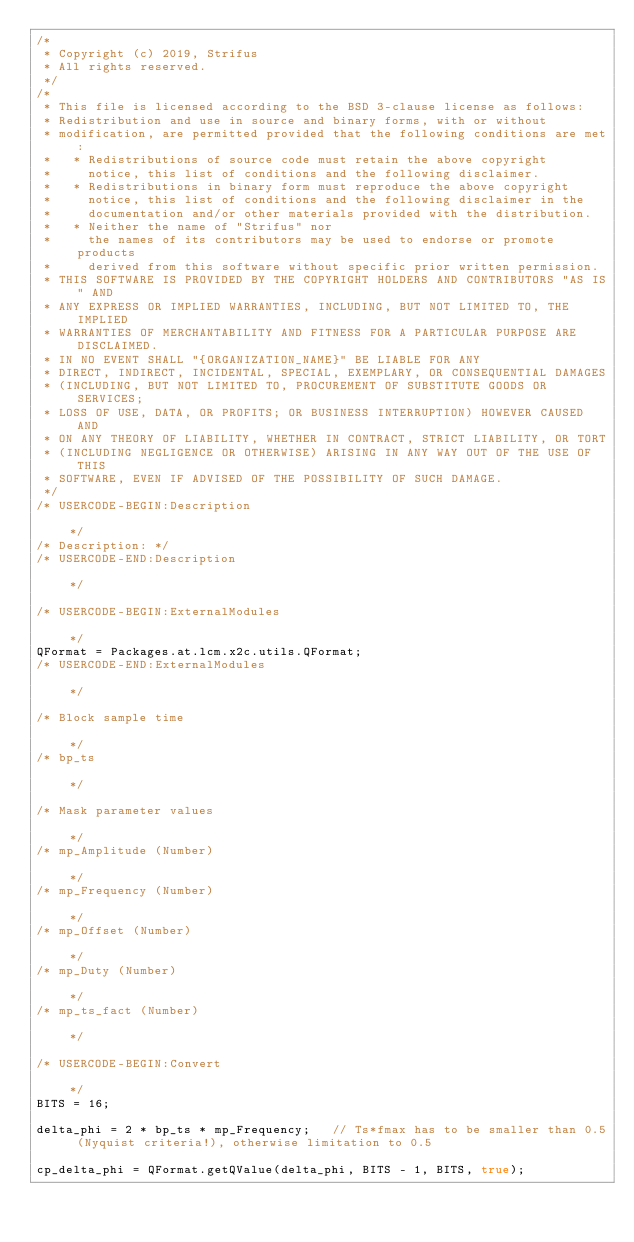<code> <loc_0><loc_0><loc_500><loc_500><_JavaScript_>/*
 * Copyright (c) 2019, Strifus
 * All rights reserved.
 */
/*
 * This file is licensed according to the BSD 3-clause license as follows:
 * Redistribution and use in source and binary forms, with or without
 * modification, are permitted provided that the following conditions are met:
 *   * Redistributions of source code must retain the above copyright
 *     notice, this list of conditions and the following disclaimer.
 *   * Redistributions in binary form must reproduce the above copyright
 *     notice, this list of conditions and the following disclaimer in the
 *     documentation and/or other materials provided with the distribution.
 *   * Neither the name of "Strifus" nor
 *     the names of its contributors may be used to endorse or promote products
 *     derived from this software without specific prior written permission.
 * THIS SOFTWARE IS PROVIDED BY THE COPYRIGHT HOLDERS AND CONTRIBUTORS "AS IS" AND
 * ANY EXPRESS OR IMPLIED WARRANTIES, INCLUDING, BUT NOT LIMITED TO, THE IMPLIED
 * WARRANTIES OF MERCHANTABILITY AND FITNESS FOR A PARTICULAR PURPOSE ARE DISCLAIMED.
 * IN NO EVENT SHALL "{ORGANIZATION_NAME}" BE LIABLE FOR ANY
 * DIRECT, INDIRECT, INCIDENTAL, SPECIAL, EXEMPLARY, OR CONSEQUENTIAL DAMAGES
 * (INCLUDING, BUT NOT LIMITED TO, PROCUREMENT OF SUBSTITUTE GOODS OR SERVICES;
 * LOSS OF USE, DATA, OR PROFITS; OR BUSINESS INTERRUPTION) HOWEVER CAUSED AND
 * ON ANY THEORY OF LIABILITY, WHETHER IN CONTRACT, STRICT LIABILITY, OR TORT
 * (INCLUDING NEGLIGENCE OR OTHERWISE) ARISING IN ANY WAY OUT OF THE USE OF THIS
 * SOFTWARE, EVEN IF ADVISED OF THE POSSIBILITY OF SUCH DAMAGE.
 */
/* USERCODE-BEGIN:Description                                                                                         */
/* Description: */
/* USERCODE-END:Description                                                                                           */

/* USERCODE-BEGIN:ExternalModules                                                                                     */
QFormat = Packages.at.lcm.x2c.utils.QFormat;
/* USERCODE-END:ExternalModules                                                                                       */

/* Block sample time                                                                                                  */
/* bp_ts                                                                                                              */

/* Mask parameter values                                                                                              */
/* mp_Amplitude (Number)                                                                                              */
/* mp_Frequency (Number)                                                                                              */
/* mp_Offset (Number)                                                                                                 */
/* mp_Duty (Number)                                                                                                   */
/* mp_ts_fact (Number)                                                                                                */

/* USERCODE-BEGIN:Convert                                                                                             */
BITS = 16;

delta_phi = 2 * bp_ts * mp_Frequency;	// Ts*fmax has to be smaller than 0.5 (Nyquist criteria!), otherwise limitation to 0.5

cp_delta_phi = QFormat.getQValue(delta_phi, BITS - 1, BITS, true);</code> 